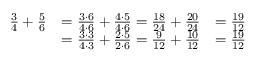<formula> <loc_0><loc_0><loc_500><loc_500>{ \begin{array} { r l r } { { \frac { 3 } { 4 } } + { \frac { 5 } { 6 } } } & { = { \frac { 3 \cdot 6 } { 4 \cdot 6 } } + { \frac { 4 \cdot 5 } { 4 \cdot 6 } } = { \frac { 1 8 } { 2 4 } } + { \frac { 2 0 } { 2 4 } } } & { = { \frac { 1 9 } { 1 2 } } } \\ & { = { \frac { 3 \cdot 3 } { 4 \cdot 3 } } + { \frac { 2 \cdot 5 } { 2 \cdot 6 } } = { \frac { 9 } { 1 2 } } + { \frac { 1 0 } { 1 2 } } } & { = { \frac { 1 9 } { 1 2 } } } \end{array} }</formula> 